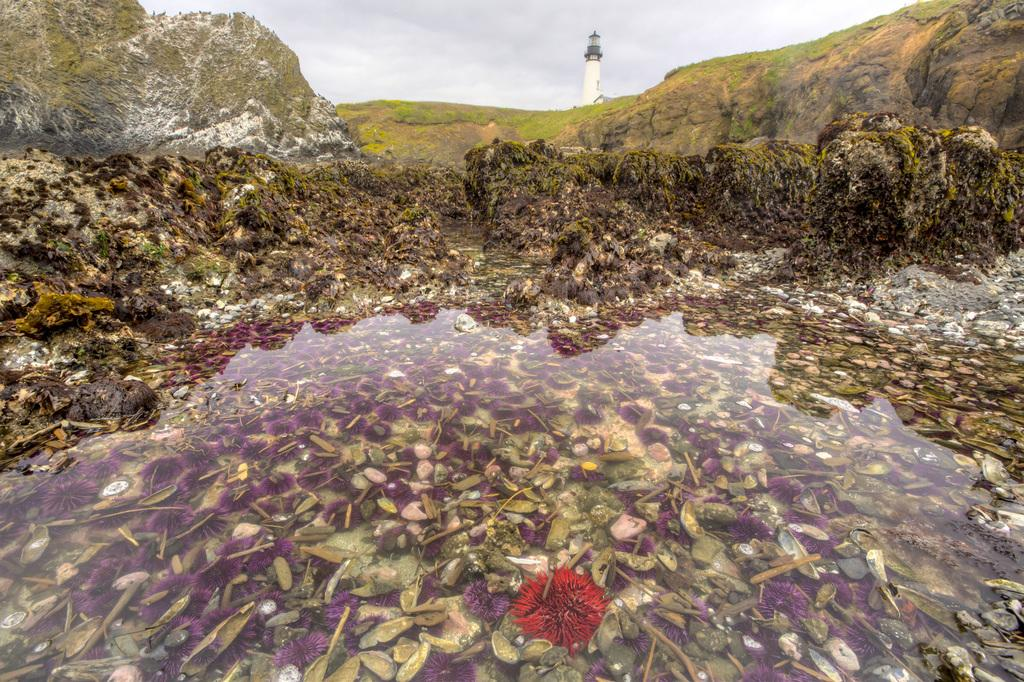What type of plants can be seen in the image? There are flowers in the image. What other objects or elements can be seen in the image? There are stones, water, mountains, grass, a tower, and the sky visible in the image. Can you describe the describe the terrain in the image? The image features a landscape with mountains, grass, and water. What structure is present in the image? There is a tower in the image. What is visible in the background of the image? The sky is visible in the background of the image. What type of horn can be seen on the tower in the image? There is no horn present on the tower in the image. What flavor of pie is being served at the picnic in the image? There is no picnic or pie present in the image. 